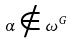Convert formula to latex. <formula><loc_0><loc_0><loc_500><loc_500>\alpha \notin \omega ^ { G }</formula> 